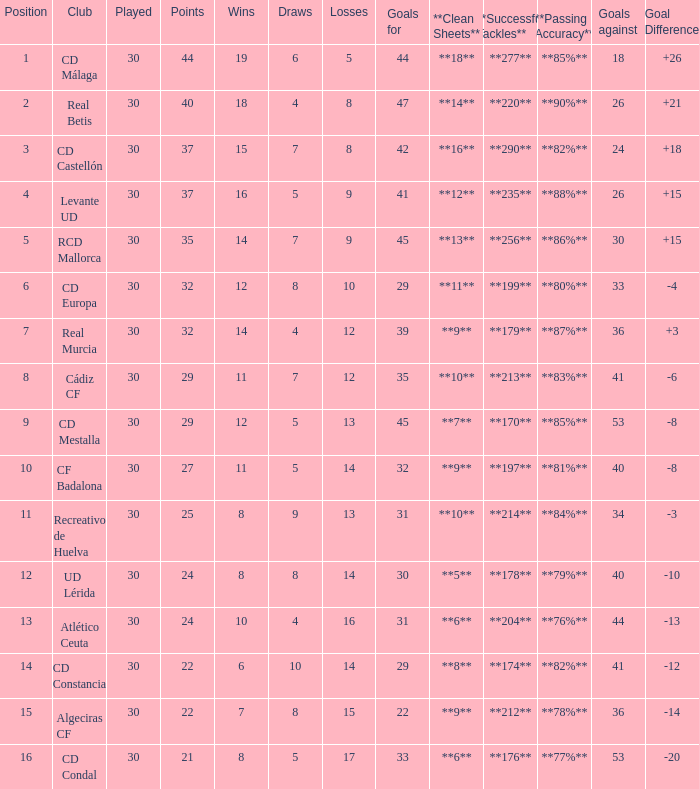Could you help me parse every detail presented in this table? {'header': ['Position', 'Club', 'Played', 'Points', 'Wins', 'Draws', 'Losses', 'Goals for', '**Clean Sheets**', '**Successful Tackles**', '**Passing Accuracy**', 'Goals against', 'Goal Difference'], 'rows': [['1', 'CD Málaga', '30', '44', '19', '6', '5', '44', '**18**', '**277**', '**85%**', '18', '+26'], ['2', 'Real Betis', '30', '40', '18', '4', '8', '47', '**14**', '**220**', '**90%**', '26', '+21'], ['3', 'CD Castellón', '30', '37', '15', '7', '8', '42', '**16**', '**290**', '**82%**', '24', '+18'], ['4', 'Levante UD', '30', '37', '16', '5', '9', '41', '**12**', '**235**', '**88%**', '26', '+15'], ['5', 'RCD Mallorca', '30', '35', '14', '7', '9', '45', '**13**', '**256**', '**86%**', '30', '+15'], ['6', 'CD Europa', '30', '32', '12', '8', '10', '29', '**11**', '**199**', '**80%**', '33', '-4'], ['7', 'Real Murcia', '30', '32', '14', '4', '12', '39', '**9**', '**179**', '**87%**', '36', '+3'], ['8', 'Cádiz CF', '30', '29', '11', '7', '12', '35', '**10**', '**213**', '**83%**', '41', '-6'], ['9', 'CD Mestalla', '30', '29', '12', '5', '13', '45', '**7**', '**170**', '**85%**', '53', '-8'], ['10', 'CF Badalona', '30', '27', '11', '5', '14', '32', '**9**', '**197**', '**81%**', '40', '-8'], ['11', 'Recreativo de Huelva', '30', '25', '8', '9', '13', '31', '**10**', '**214**', '**84%**', '34', '-3'], ['12', 'UD Lérida', '30', '24', '8', '8', '14', '30', '**5**', '**178**', '**79%**', '40', '-10'], ['13', 'Atlético Ceuta', '30', '24', '10', '4', '16', '31', '**6**', '**204**', '**76%**', '44', '-13'], ['14', 'CD Constancia', '30', '22', '6', '10', '14', '29', '**8**', '**174**', '**82%**', '41', '-12'], ['15', 'Algeciras CF', '30', '22', '7', '8', '15', '22', '**9**', '**212**', '**78%**', '36', '-14'], ['16', 'CD Condal', '30', '21', '8', '5', '17', '33', '**6**', '**176**', '**77%**', '53', '-20']]} What is the number of wins when the goals against is larger than 41, points is 29, and draws are larger than 5? 0.0. 